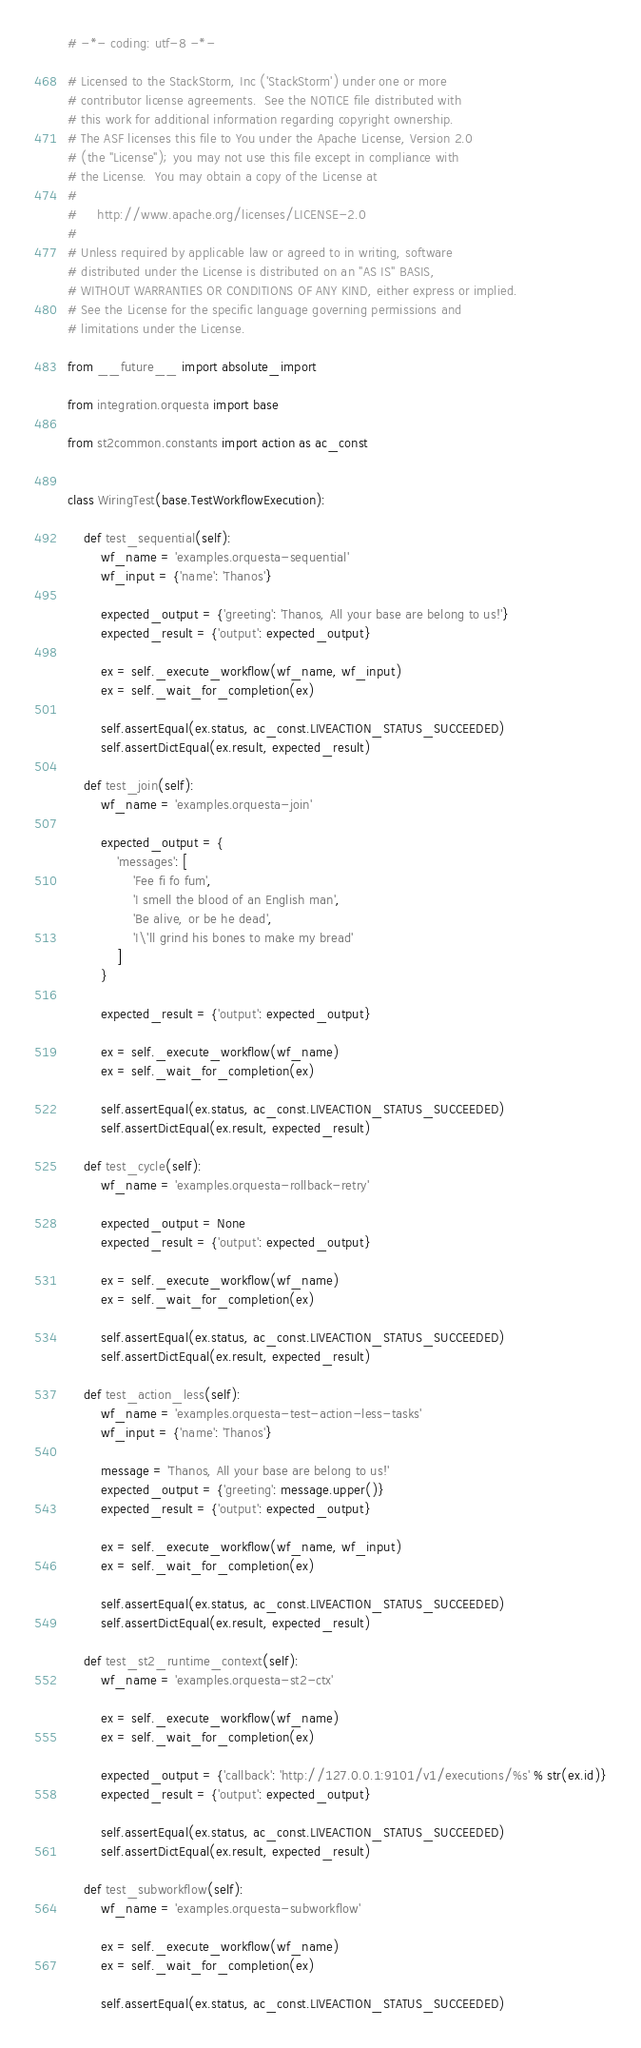Convert code to text. <code><loc_0><loc_0><loc_500><loc_500><_Python_># -*- coding: utf-8 -*-

# Licensed to the StackStorm, Inc ('StackStorm') under one or more
# contributor license agreements.  See the NOTICE file distributed with
# this work for additional information regarding copyright ownership.
# The ASF licenses this file to You under the Apache License, Version 2.0
# (the "License"); you may not use this file except in compliance with
# the License.  You may obtain a copy of the License at
#
#     http://www.apache.org/licenses/LICENSE-2.0
#
# Unless required by applicable law or agreed to in writing, software
# distributed under the License is distributed on an "AS IS" BASIS,
# WITHOUT WARRANTIES OR CONDITIONS OF ANY KIND, either express or implied.
# See the License for the specific language governing permissions and
# limitations under the License.

from __future__ import absolute_import

from integration.orquesta import base

from st2common.constants import action as ac_const


class WiringTest(base.TestWorkflowExecution):

    def test_sequential(self):
        wf_name = 'examples.orquesta-sequential'
        wf_input = {'name': 'Thanos'}

        expected_output = {'greeting': 'Thanos, All your base are belong to us!'}
        expected_result = {'output': expected_output}

        ex = self._execute_workflow(wf_name, wf_input)
        ex = self._wait_for_completion(ex)

        self.assertEqual(ex.status, ac_const.LIVEACTION_STATUS_SUCCEEDED)
        self.assertDictEqual(ex.result, expected_result)

    def test_join(self):
        wf_name = 'examples.orquesta-join'

        expected_output = {
            'messages': [
                'Fee fi fo fum',
                'I smell the blood of an English man',
                'Be alive, or be he dead',
                'I\'ll grind his bones to make my bread'
            ]
        }

        expected_result = {'output': expected_output}

        ex = self._execute_workflow(wf_name)
        ex = self._wait_for_completion(ex)

        self.assertEqual(ex.status, ac_const.LIVEACTION_STATUS_SUCCEEDED)
        self.assertDictEqual(ex.result, expected_result)

    def test_cycle(self):
        wf_name = 'examples.orquesta-rollback-retry'

        expected_output = None
        expected_result = {'output': expected_output}

        ex = self._execute_workflow(wf_name)
        ex = self._wait_for_completion(ex)

        self.assertEqual(ex.status, ac_const.LIVEACTION_STATUS_SUCCEEDED)
        self.assertDictEqual(ex.result, expected_result)

    def test_action_less(self):
        wf_name = 'examples.orquesta-test-action-less-tasks'
        wf_input = {'name': 'Thanos'}

        message = 'Thanos, All your base are belong to us!'
        expected_output = {'greeting': message.upper()}
        expected_result = {'output': expected_output}

        ex = self._execute_workflow(wf_name, wf_input)
        ex = self._wait_for_completion(ex)

        self.assertEqual(ex.status, ac_const.LIVEACTION_STATUS_SUCCEEDED)
        self.assertDictEqual(ex.result, expected_result)

    def test_st2_runtime_context(self):
        wf_name = 'examples.orquesta-st2-ctx'

        ex = self._execute_workflow(wf_name)
        ex = self._wait_for_completion(ex)

        expected_output = {'callback': 'http://127.0.0.1:9101/v1/executions/%s' % str(ex.id)}
        expected_result = {'output': expected_output}

        self.assertEqual(ex.status, ac_const.LIVEACTION_STATUS_SUCCEEDED)
        self.assertDictEqual(ex.result, expected_result)

    def test_subworkflow(self):
        wf_name = 'examples.orquesta-subworkflow'

        ex = self._execute_workflow(wf_name)
        ex = self._wait_for_completion(ex)

        self.assertEqual(ex.status, ac_const.LIVEACTION_STATUS_SUCCEEDED)
</code> 